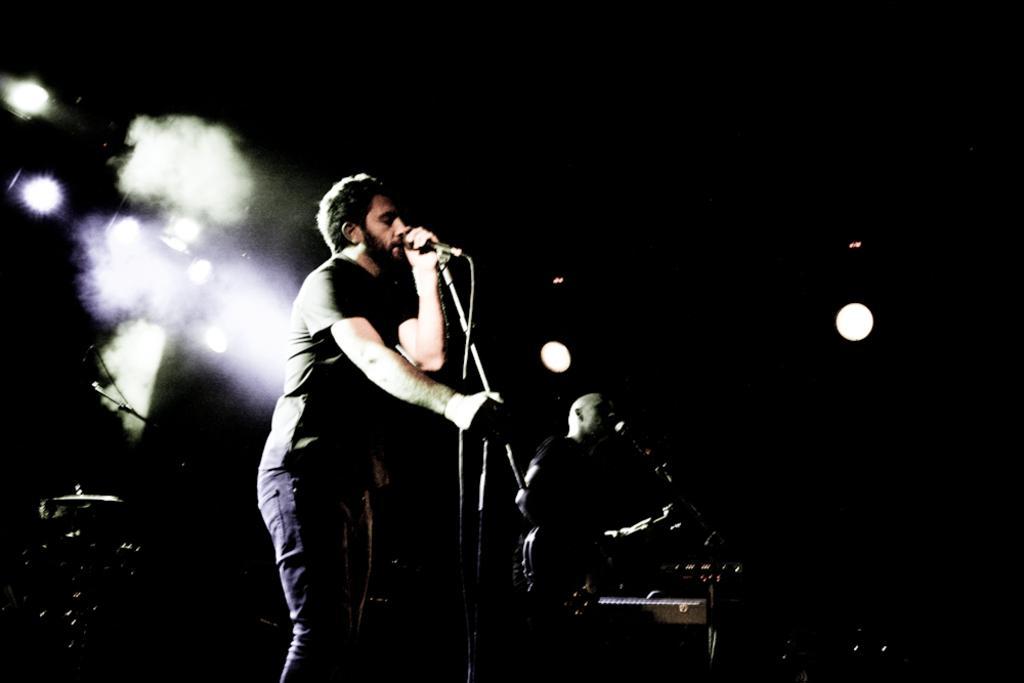Please provide a concise description of this image. In the picture we can see some persons standing on stage and playing musical instruments, in the background of the picture there are some lights and there is dark view. 